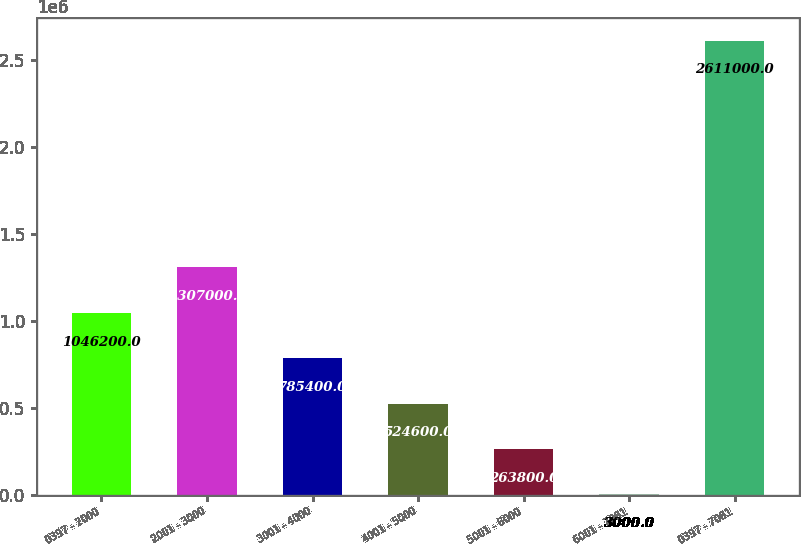Convert chart. <chart><loc_0><loc_0><loc_500><loc_500><bar_chart><fcel>0397 - 2000<fcel>2001 - 3000<fcel>3001 - 4000<fcel>4001 - 5000<fcel>5001 - 6000<fcel>6001 - 7081<fcel>0397 - 7081<nl><fcel>1.0462e+06<fcel>1.307e+06<fcel>785400<fcel>524600<fcel>263800<fcel>3000<fcel>2.611e+06<nl></chart> 